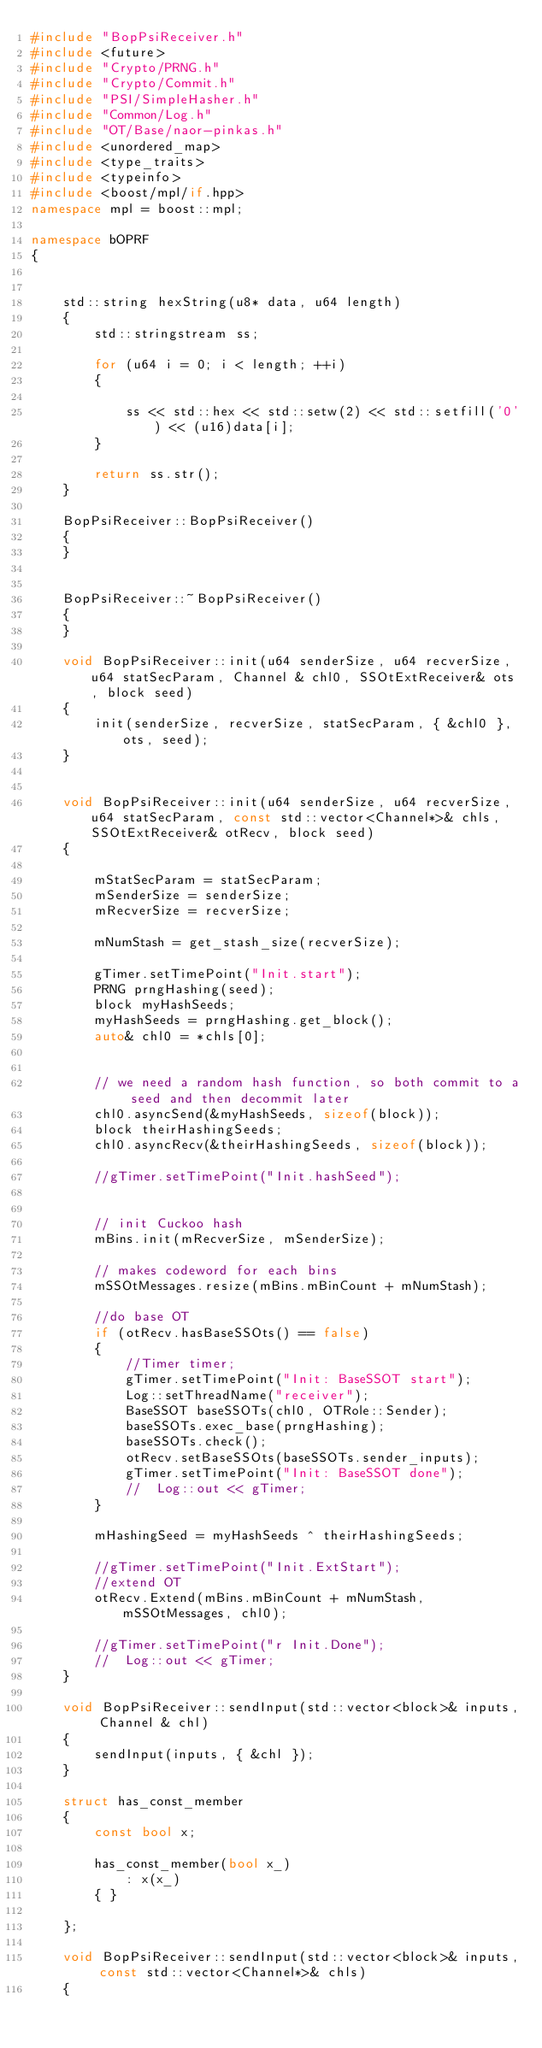<code> <loc_0><loc_0><loc_500><loc_500><_C++_>#include "BopPsiReceiver.h"
#include <future>
#include "Crypto/PRNG.h"
#include "Crypto/Commit.h"
#include "PSI/SimpleHasher.h"
#include "Common/Log.h"
#include "OT/Base/naor-pinkas.h"
#include <unordered_map>
#include <type_traits>
#include <typeinfo>
#include <boost/mpl/if.hpp>
namespace mpl = boost::mpl;

namespace bOPRF
{


	std::string hexString(u8* data, u64 length)
	{
		std::stringstream ss;

		for (u64 i = 0; i < length; ++i)
		{

			ss << std::hex << std::setw(2) << std::setfill('0') << (u16)data[i];
		}

		return ss.str();
	}

	BopPsiReceiver::BopPsiReceiver()
	{
	}


	BopPsiReceiver::~BopPsiReceiver()
	{
	}

	void BopPsiReceiver::init(u64 senderSize, u64 recverSize, u64 statSecParam, Channel & chl0, SSOtExtReceiver& ots, block seed)
	{
		init(senderSize, recverSize, statSecParam, { &chl0 }, ots, seed);
	}


	void BopPsiReceiver::init(u64 senderSize, u64 recverSize, u64 statSecParam, const std::vector<Channel*>& chls, SSOtExtReceiver& otRecv, block seed)
	{

		mStatSecParam = statSecParam;
		mSenderSize = senderSize;
		mRecverSize = recverSize;

		mNumStash = get_stash_size(recverSize);

		gTimer.setTimePoint("Init.start");
		PRNG prngHashing(seed);
		block myHashSeeds;
		myHashSeeds = prngHashing.get_block();
		auto& chl0 = *chls[0];


		// we need a random hash function, so both commit to a seed and then decommit later
		chl0.asyncSend(&myHashSeeds, sizeof(block));
		block theirHashingSeeds;
		chl0.asyncRecv(&theirHashingSeeds, sizeof(block));

		//gTimer.setTimePoint("Init.hashSeed");


		// init Cuckoo hash
		mBins.init(mRecverSize, mSenderSize);

		// makes codeword for each bins
		mSSOtMessages.resize(mBins.mBinCount + mNumStash);

		//do base OT
		if (otRecv.hasBaseSSOts() == false)
		{
			//Timer timer;
			gTimer.setTimePoint("Init: BaseSSOT start");
			Log::setThreadName("receiver");
			BaseSSOT baseSSOTs(chl0, OTRole::Sender);
			baseSSOTs.exec_base(prngHashing);
			baseSSOTs.check();
			otRecv.setBaseSSOts(baseSSOTs.sender_inputs);
			gTimer.setTimePoint("Init: BaseSSOT done");
			//	Log::out << gTimer;
		}

		mHashingSeed = myHashSeeds ^ theirHashingSeeds;

		//gTimer.setTimePoint("Init.ExtStart");
		//extend OT
		otRecv.Extend(mBins.mBinCount + mNumStash, mSSOtMessages, chl0);

		//gTimer.setTimePoint("r Init.Done");
		//	Log::out << gTimer;
	}

	void BopPsiReceiver::sendInput(std::vector<block>& inputs, Channel & chl)
	{
		sendInput(inputs, { &chl });
	}

	struct has_const_member
	{
		const bool x;

		has_const_member(bool x_)
			: x(x_)
		{ }

	};

	void BopPsiReceiver::sendInput(std::vector<block>& inputs, const std::vector<Channel*>& chls)
	{



</code> 